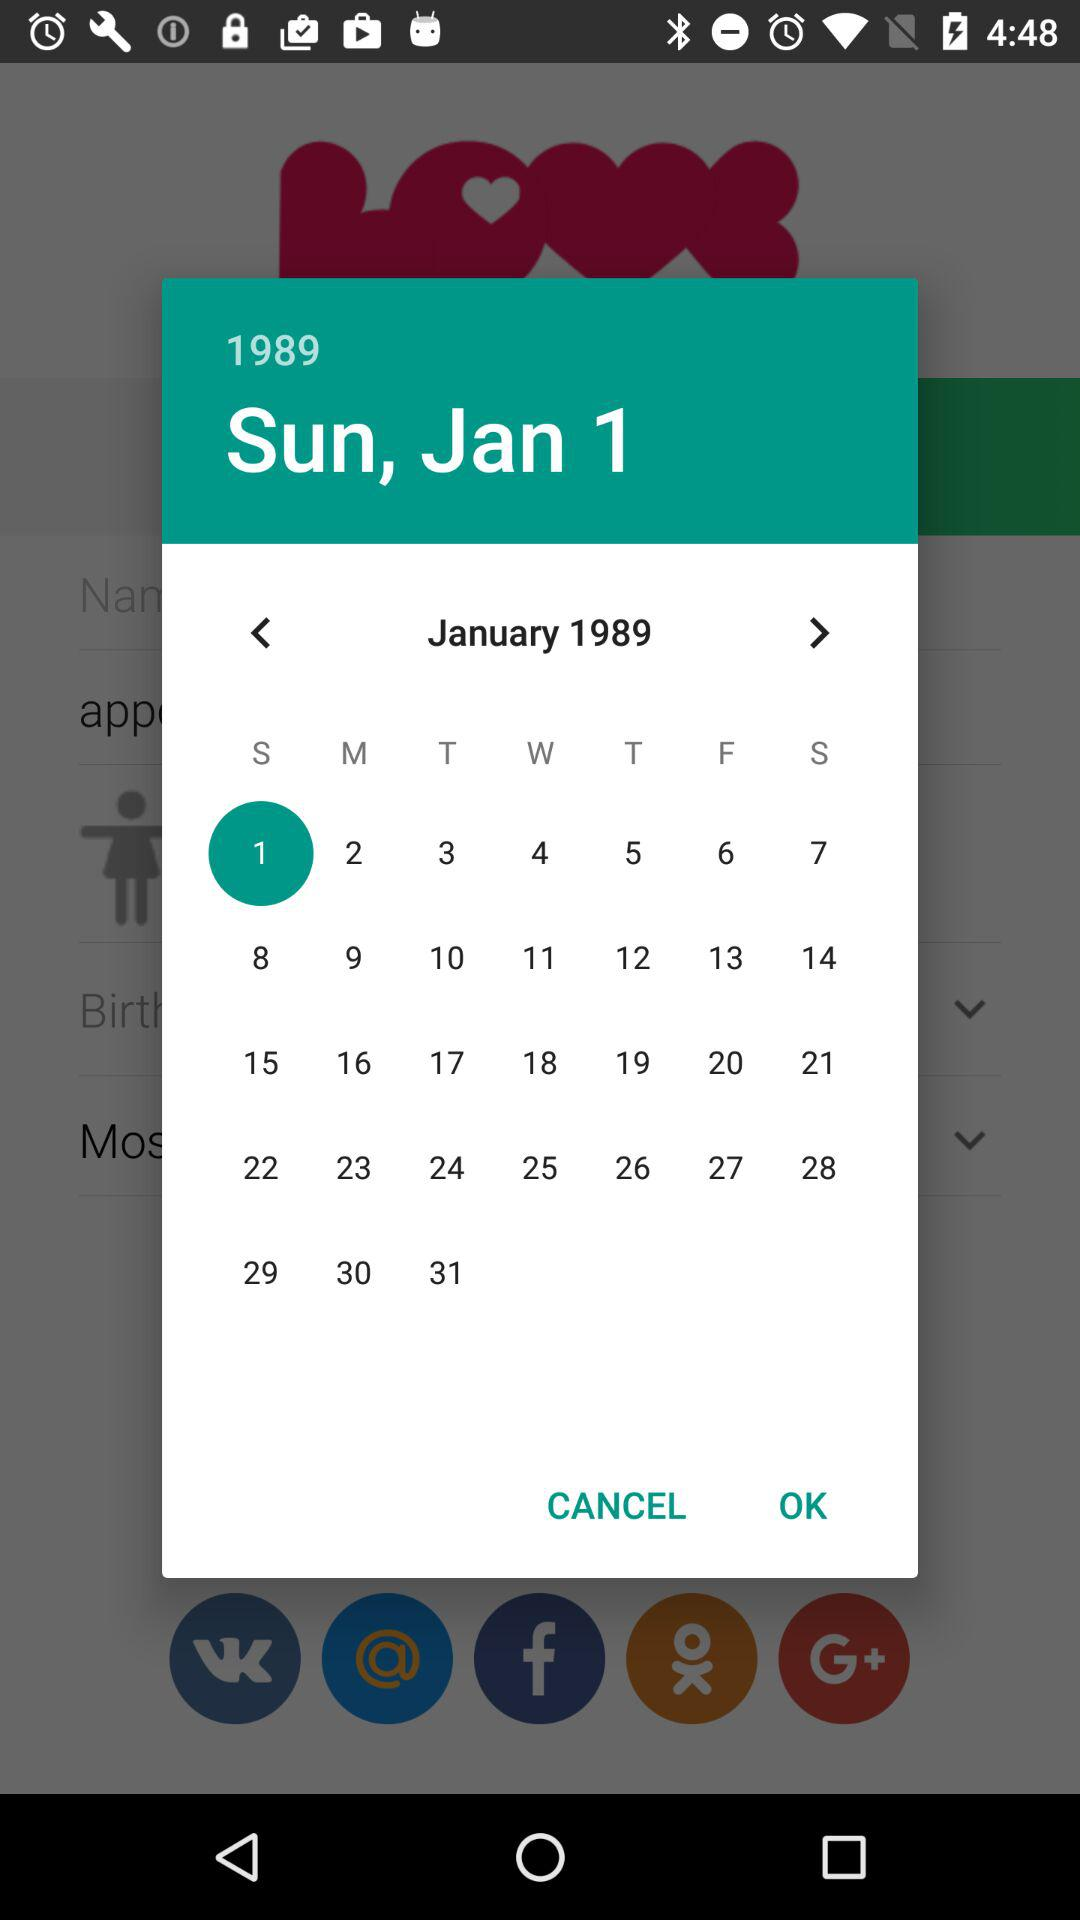What is the year? The year is 1989. 